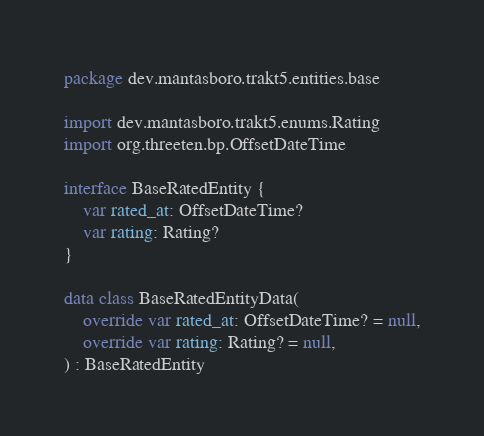Convert code to text. <code><loc_0><loc_0><loc_500><loc_500><_Kotlin_>package dev.mantasboro.trakt5.entities.base

import dev.mantasboro.trakt5.enums.Rating
import org.threeten.bp.OffsetDateTime

interface BaseRatedEntity {
    var rated_at: OffsetDateTime?
    var rating: Rating?
}

data class BaseRatedEntityData(
    override var rated_at: OffsetDateTime? = null,
    override var rating: Rating? = null,
) : BaseRatedEntity
</code> 